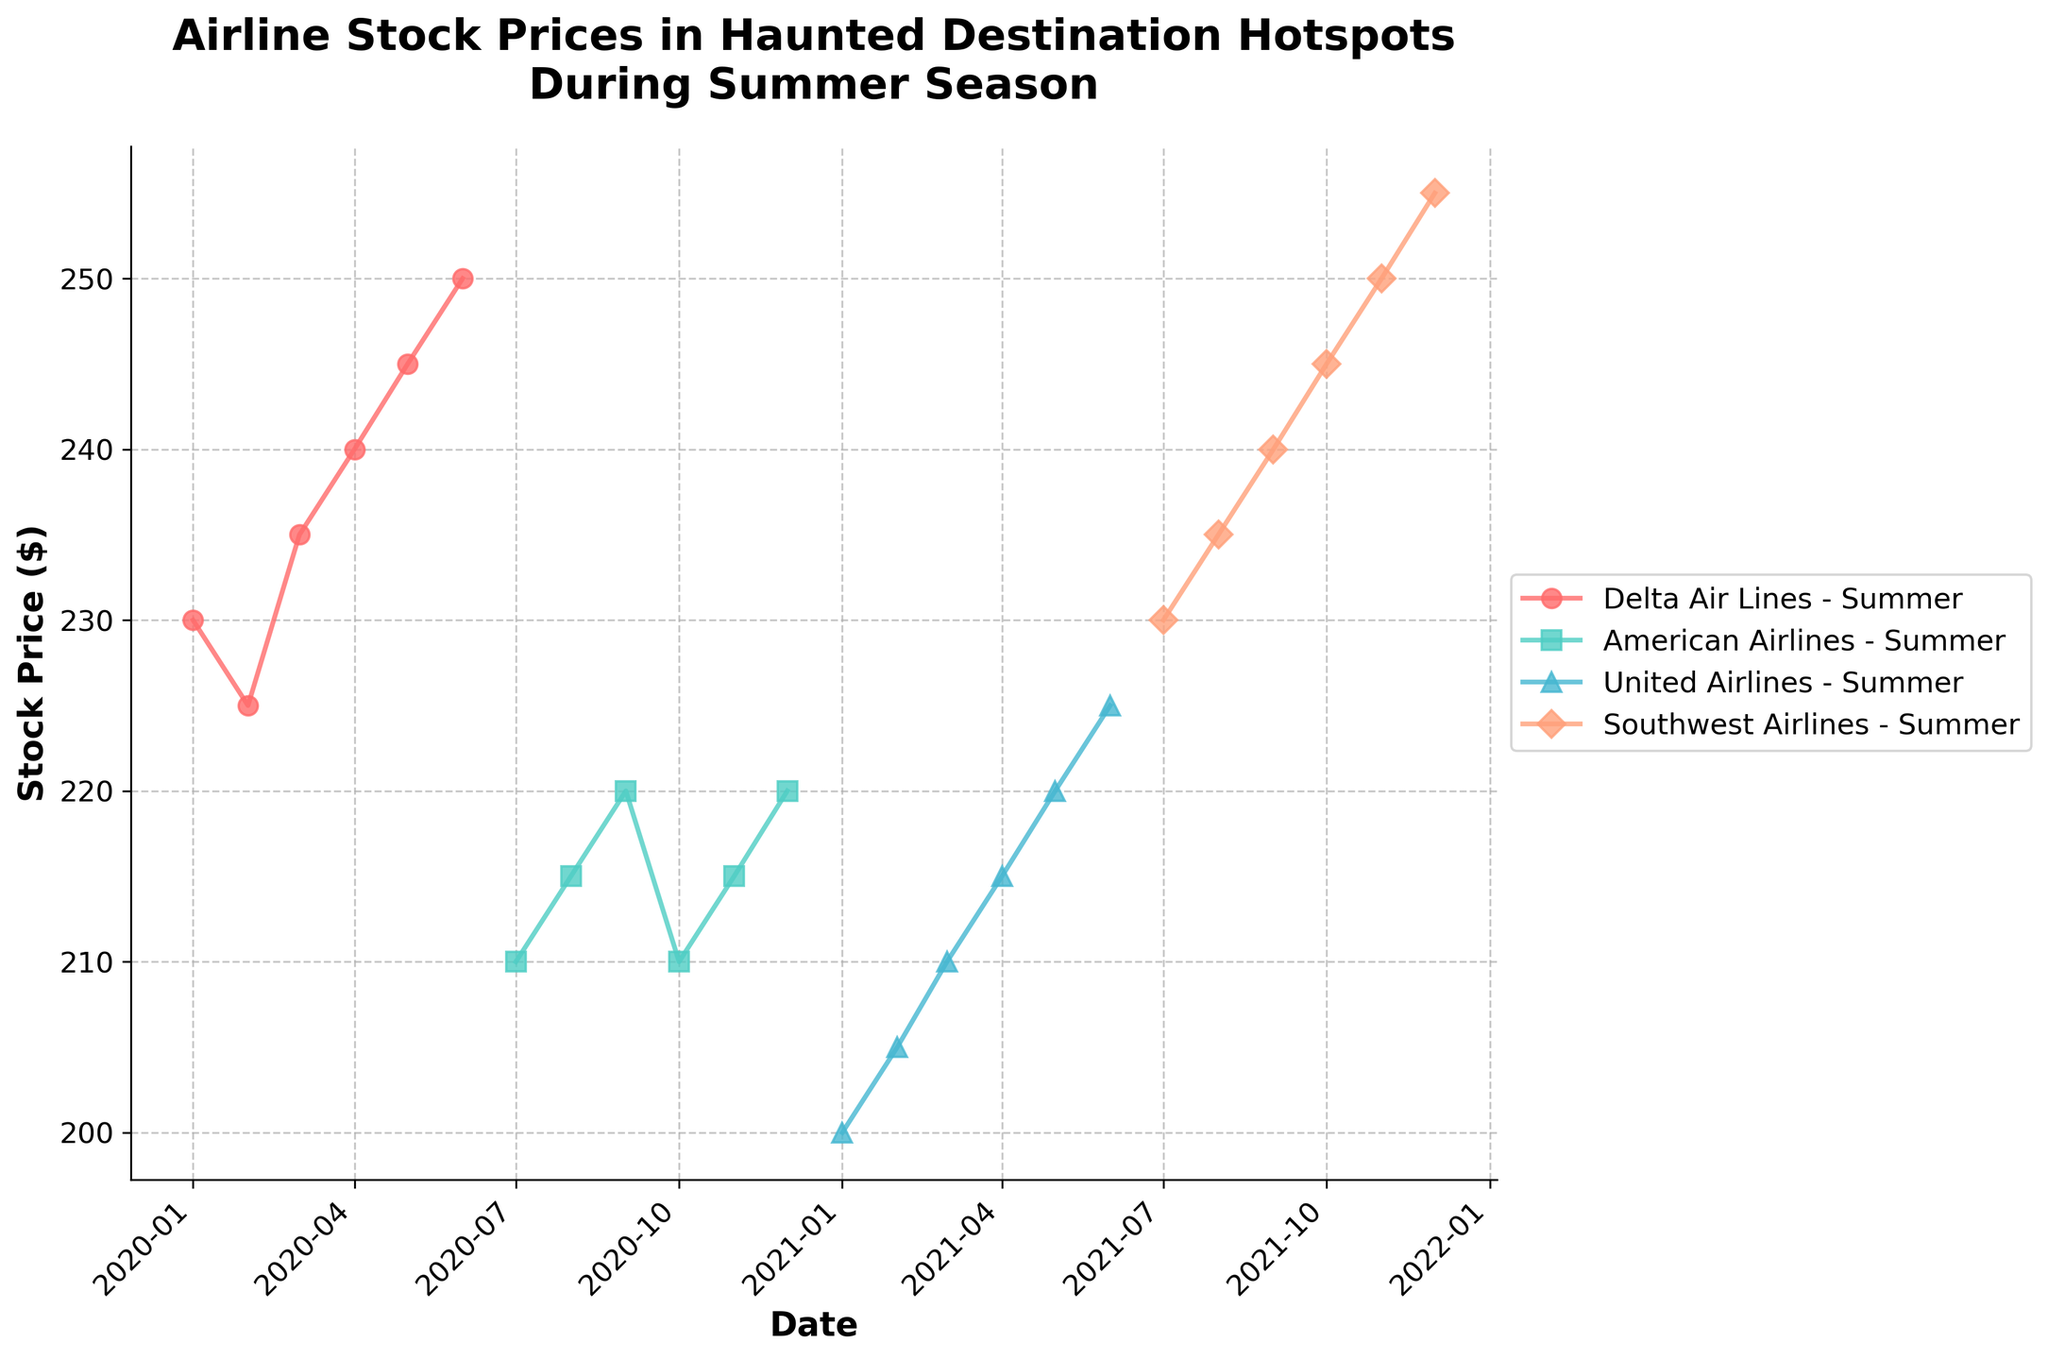What is the title of the plot? The title of the plot is displayed prominently at the top and reads "Airline Stock Prices in Haunted Destination Hotspots During Summer Season".
Answer: Airline Stock Prices in Haunted Destination Hotspots During Summer Season What is the stock price for Delta Air Lines in June 2020? To find the stock price for Delta Air Lines in June 2020, locate the point on the plot labeled "Delta Air Lines" on the x-axis corresponding to June 2020 and read the y-axis value of the data point.
Answer: 250 Which airline has the highest stock price in December 2021? To determine the airline with the highest stock price in December 2021, compare the y-axis values of the December 2021 data points for all represented airlines. Southwest Airlines has the highest value.
Answer: Southwest Airlines How does the stock price of American Airlines change from July 2020 to December 2020? Look at the plotted data points for American Airlines in July 2020 and December 2020. The stock price increases from around 210 to 220, showing a gradual increase over this period.
Answer: It increases by 10 units What is the difference in stock price between Delta Air Lines and Southwest Airlines in August 2021? Compare the y-axis values for Delta Air Lines and Southwest Airlines for August 2021 data points. If Delta Air Lines is not present in August 2021, the comparison cannot be made.
Answer: Not applicable Which season generally shows the highest stock prices for Delta Air Lines? Observe the different seasonal stock price trends for Delta Air Lines across multiple months and compare them. Notice that summer consistently has higher prices compared to the other seasons.
Answer: Summer Which airline shows the most consistent increase in stock price over the period presented? Examine the trends of all airlines and identify the one with a steady and consistent upward slope. Southwest Airlines shows a consistent increase in stock price over time.
Answer: Southwest Airlines Is there a noticeable trend in the stock prices during the summer season across all airlines? Evaluate the plotted lines for the summer season across all airlines and look for a general trend. The stock prices generally increase during the summer months.
Answer: Yes, they generally increase What could be the reason for the seasonal spike in stock prices for these airlines? Seasonal spikes in airline stock prices could be due to increased travel during summer vacations when more people are likely to fly, especially to destinations with haunted attractions. Summertime often sees higher airline revenues, leading to higher stock prices.
Answer: Increased summer travel 